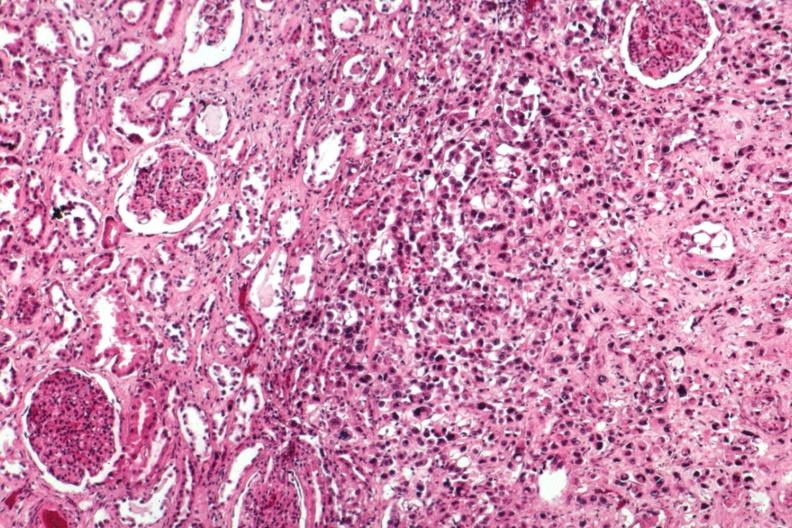where is this?
Answer the question using a single word or phrase. Urinary 